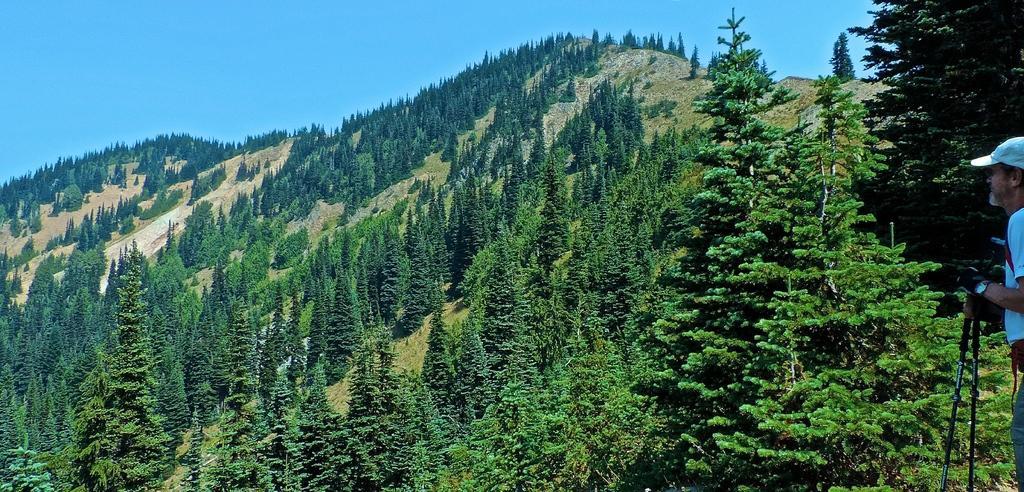How would you summarize this image in a sentence or two? This picture is clicked outside the city. On the right corner there is a person holding some object and seems to be standing on the ground. In the center we can see the hills and the trees. In the background there is a sky. 